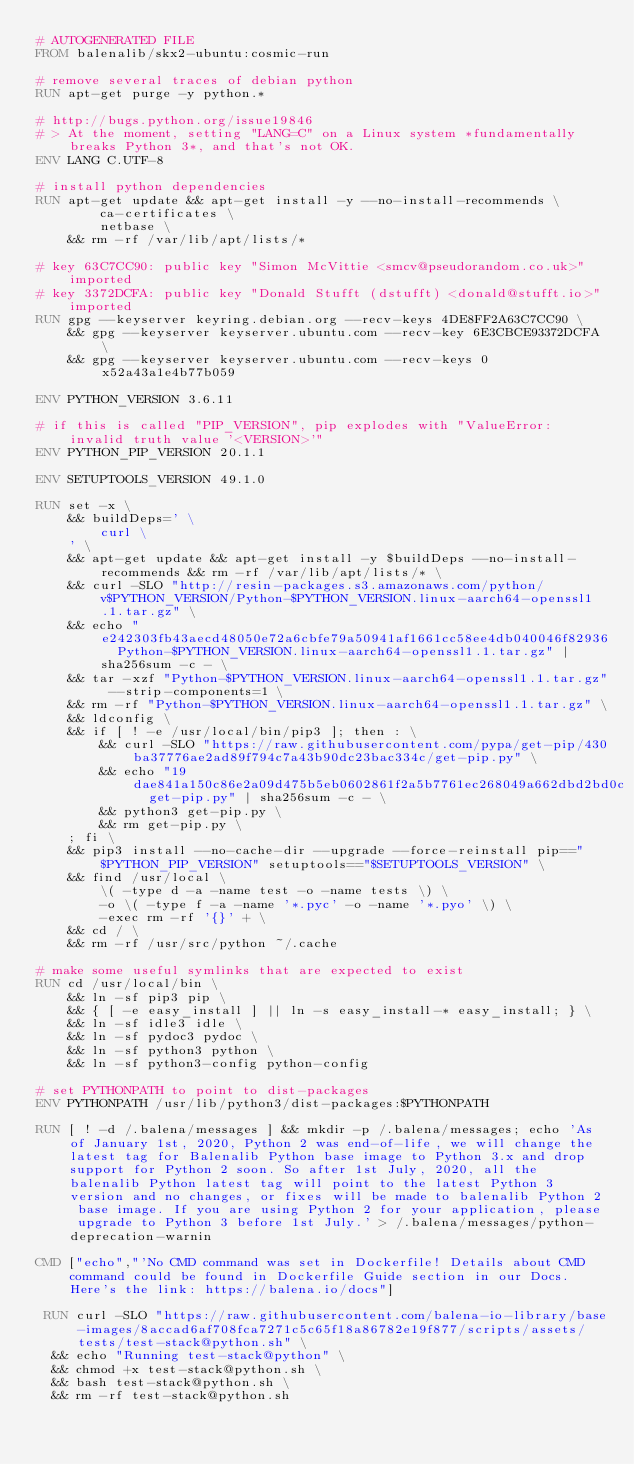Convert code to text. <code><loc_0><loc_0><loc_500><loc_500><_Dockerfile_># AUTOGENERATED FILE
FROM balenalib/skx2-ubuntu:cosmic-run

# remove several traces of debian python
RUN apt-get purge -y python.*

# http://bugs.python.org/issue19846
# > At the moment, setting "LANG=C" on a Linux system *fundamentally breaks Python 3*, and that's not OK.
ENV LANG C.UTF-8

# install python dependencies
RUN apt-get update && apt-get install -y --no-install-recommends \
		ca-certificates \
		netbase \
	&& rm -rf /var/lib/apt/lists/*

# key 63C7CC90: public key "Simon McVittie <smcv@pseudorandom.co.uk>" imported
# key 3372DCFA: public key "Donald Stufft (dstufft) <donald@stufft.io>" imported
RUN gpg --keyserver keyring.debian.org --recv-keys 4DE8FF2A63C7CC90 \
	&& gpg --keyserver keyserver.ubuntu.com --recv-key 6E3CBCE93372DCFA \
	&& gpg --keyserver keyserver.ubuntu.com --recv-keys 0x52a43a1e4b77b059

ENV PYTHON_VERSION 3.6.11

# if this is called "PIP_VERSION", pip explodes with "ValueError: invalid truth value '<VERSION>'"
ENV PYTHON_PIP_VERSION 20.1.1

ENV SETUPTOOLS_VERSION 49.1.0

RUN set -x \
	&& buildDeps=' \
		curl \
	' \
	&& apt-get update && apt-get install -y $buildDeps --no-install-recommends && rm -rf /var/lib/apt/lists/* \
	&& curl -SLO "http://resin-packages.s3.amazonaws.com/python/v$PYTHON_VERSION/Python-$PYTHON_VERSION.linux-aarch64-openssl1.1.tar.gz" \
	&& echo "e242303fb43aecd48050e72a6cbfe79a50941af1661cc58ee4db040046f82936  Python-$PYTHON_VERSION.linux-aarch64-openssl1.1.tar.gz" | sha256sum -c - \
	&& tar -xzf "Python-$PYTHON_VERSION.linux-aarch64-openssl1.1.tar.gz" --strip-components=1 \
	&& rm -rf "Python-$PYTHON_VERSION.linux-aarch64-openssl1.1.tar.gz" \
	&& ldconfig \
	&& if [ ! -e /usr/local/bin/pip3 ]; then : \
		&& curl -SLO "https://raw.githubusercontent.com/pypa/get-pip/430ba37776ae2ad89f794c7a43b90dc23bac334c/get-pip.py" \
		&& echo "19dae841a150c86e2a09d475b5eb0602861f2a5b7761ec268049a662dbd2bd0c  get-pip.py" | sha256sum -c - \
		&& python3 get-pip.py \
		&& rm get-pip.py \
	; fi \
	&& pip3 install --no-cache-dir --upgrade --force-reinstall pip=="$PYTHON_PIP_VERSION" setuptools=="$SETUPTOOLS_VERSION" \
	&& find /usr/local \
		\( -type d -a -name test -o -name tests \) \
		-o \( -type f -a -name '*.pyc' -o -name '*.pyo' \) \
		-exec rm -rf '{}' + \
	&& cd / \
	&& rm -rf /usr/src/python ~/.cache

# make some useful symlinks that are expected to exist
RUN cd /usr/local/bin \
	&& ln -sf pip3 pip \
	&& { [ -e easy_install ] || ln -s easy_install-* easy_install; } \
	&& ln -sf idle3 idle \
	&& ln -sf pydoc3 pydoc \
	&& ln -sf python3 python \
	&& ln -sf python3-config python-config

# set PYTHONPATH to point to dist-packages
ENV PYTHONPATH /usr/lib/python3/dist-packages:$PYTHONPATH

RUN [ ! -d /.balena/messages ] && mkdir -p /.balena/messages; echo 'As of January 1st, 2020, Python 2 was end-of-life, we will change the latest tag for Balenalib Python base image to Python 3.x and drop support for Python 2 soon. So after 1st July, 2020, all the balenalib Python latest tag will point to the latest Python 3 version and no changes, or fixes will be made to balenalib Python 2 base image. If you are using Python 2 for your application, please upgrade to Python 3 before 1st July.' > /.balena/messages/python-deprecation-warnin

CMD ["echo","'No CMD command was set in Dockerfile! Details about CMD command could be found in Dockerfile Guide section in our Docs. Here's the link: https://balena.io/docs"]

 RUN curl -SLO "https://raw.githubusercontent.com/balena-io-library/base-images/8accad6af708fca7271c5c65f18a86782e19f877/scripts/assets/tests/test-stack@python.sh" \
  && echo "Running test-stack@python" \
  && chmod +x test-stack@python.sh \
  && bash test-stack@python.sh \
  && rm -rf test-stack@python.sh 
</code> 